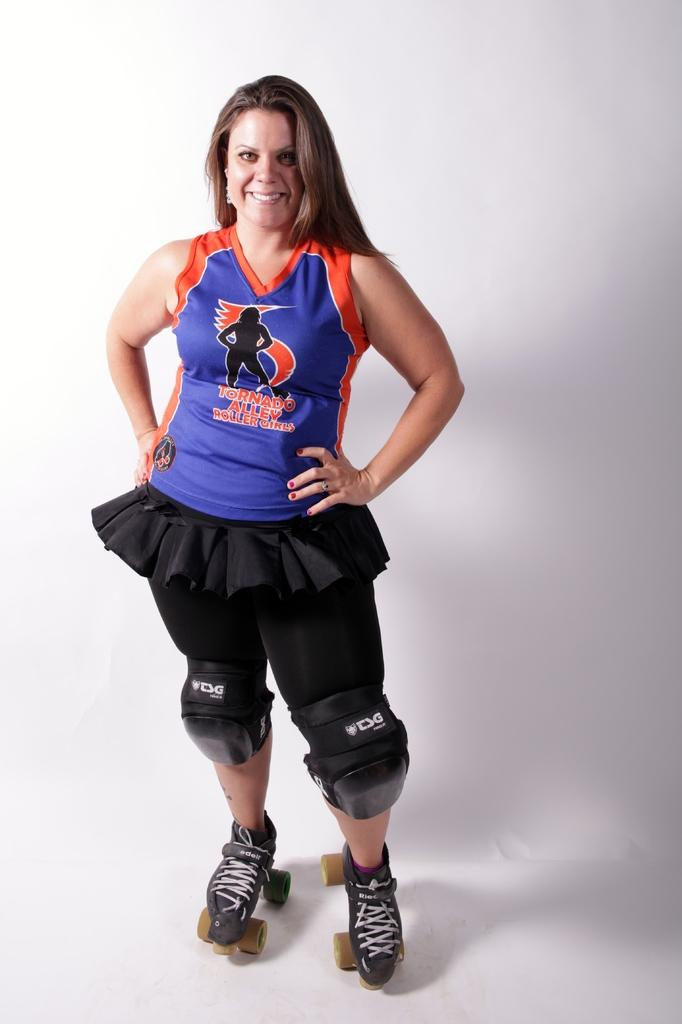<image>
Describe the image concisely. A woman wearing a blue and orange shirt that says Tornado Alley Rollergirls smiles for the camera. 